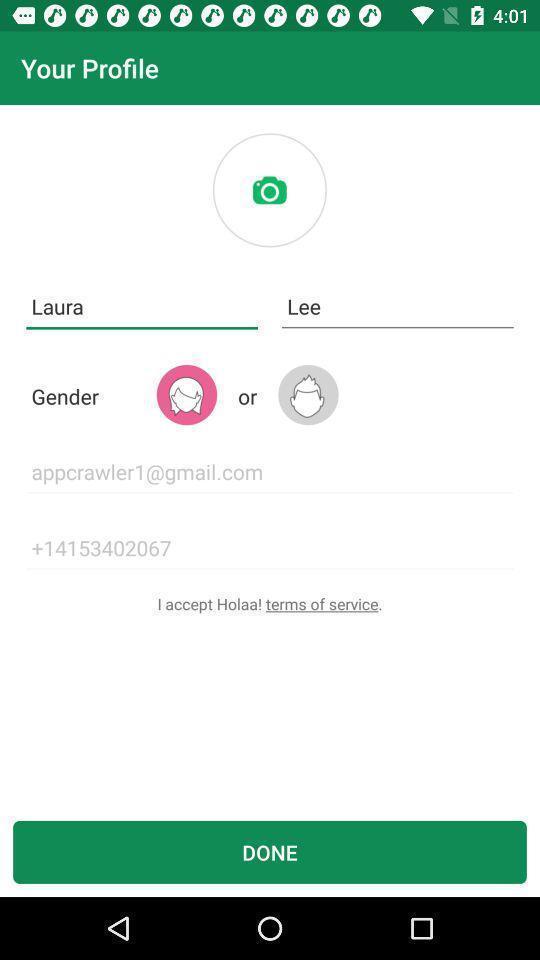Provide a description of this screenshot. Profile page. 